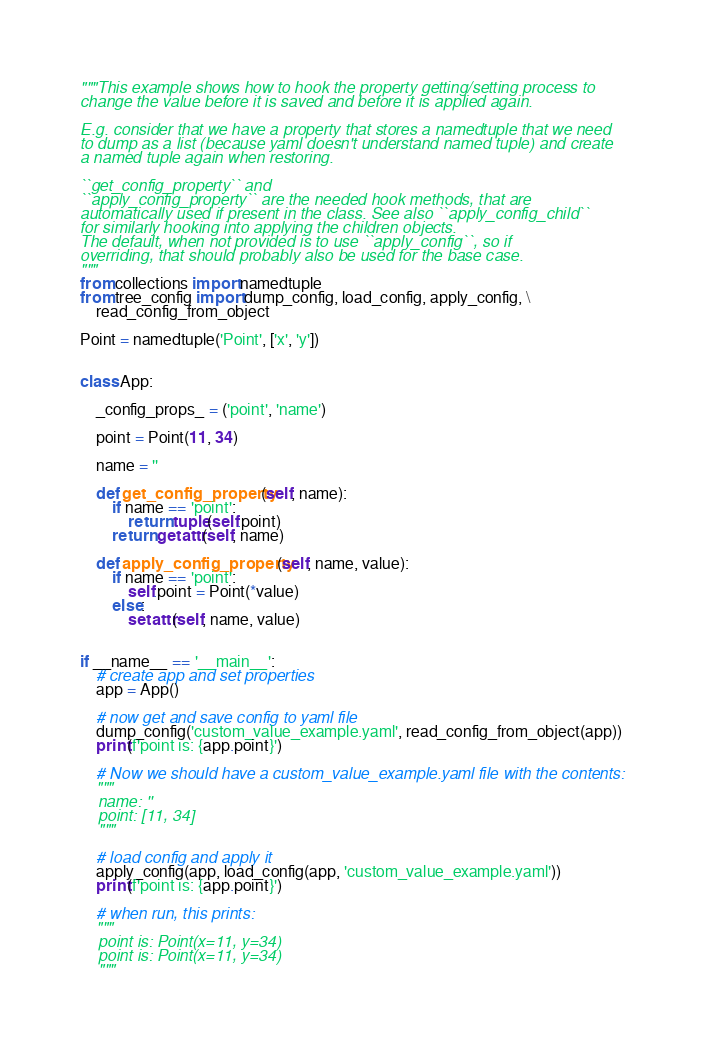<code> <loc_0><loc_0><loc_500><loc_500><_Python_>"""This example shows how to hook the property getting/setting process to
change the value before it is saved and before it is applied again.

E.g. consider that we have a property that stores a namedtuple that we need
to dump as a list (because yaml doesn't understand named tuple) and create
a named tuple again when restoring.

``get_config_property`` and
``apply_config_property`` are the needed hook methods, that are
automatically used if present in the class. See also ``apply_config_child``
for similarly hooking into applying the children objects.
The default, when not provided is to use ``apply_config``, so if
overriding, that should probably also be used for the base case.
"""
from collections import namedtuple
from tree_config import dump_config, load_config, apply_config, \
    read_config_from_object

Point = namedtuple('Point', ['x', 'y'])


class App:

    _config_props_ = ('point', 'name')

    point = Point(11, 34)

    name = ''

    def get_config_property(self, name):
        if name == 'point':
            return tuple(self.point)
        return getattr(self, name)

    def apply_config_property(self, name, value):
        if name == 'point':
            self.point = Point(*value)
        else:
            setattr(self, name, value)


if __name__ == '__main__':
    # create app and set properties
    app = App()

    # now get and save config to yaml file
    dump_config('custom_value_example.yaml', read_config_from_object(app))
    print(f'point is: {app.point}')

    # Now we should have a custom_value_example.yaml file with the contents:
    """
    name: ''
    point: [11, 34]
    """

    # load config and apply it
    apply_config(app, load_config(app, 'custom_value_example.yaml'))
    print(f'point is: {app.point}')

    # when run, this prints:
    """
    point is: Point(x=11, y=34)
    point is: Point(x=11, y=34)
    """
</code> 